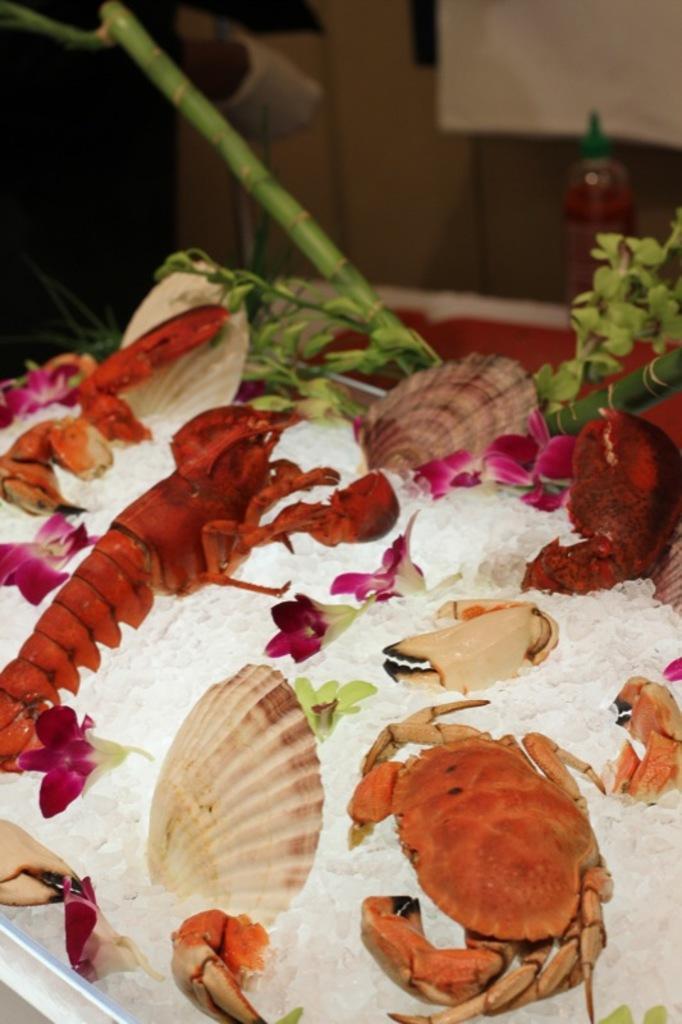Can you describe this image briefly? In the foreground of the picture we can see ice, crabs, plant and other marine animals. In the background it is blurred. 